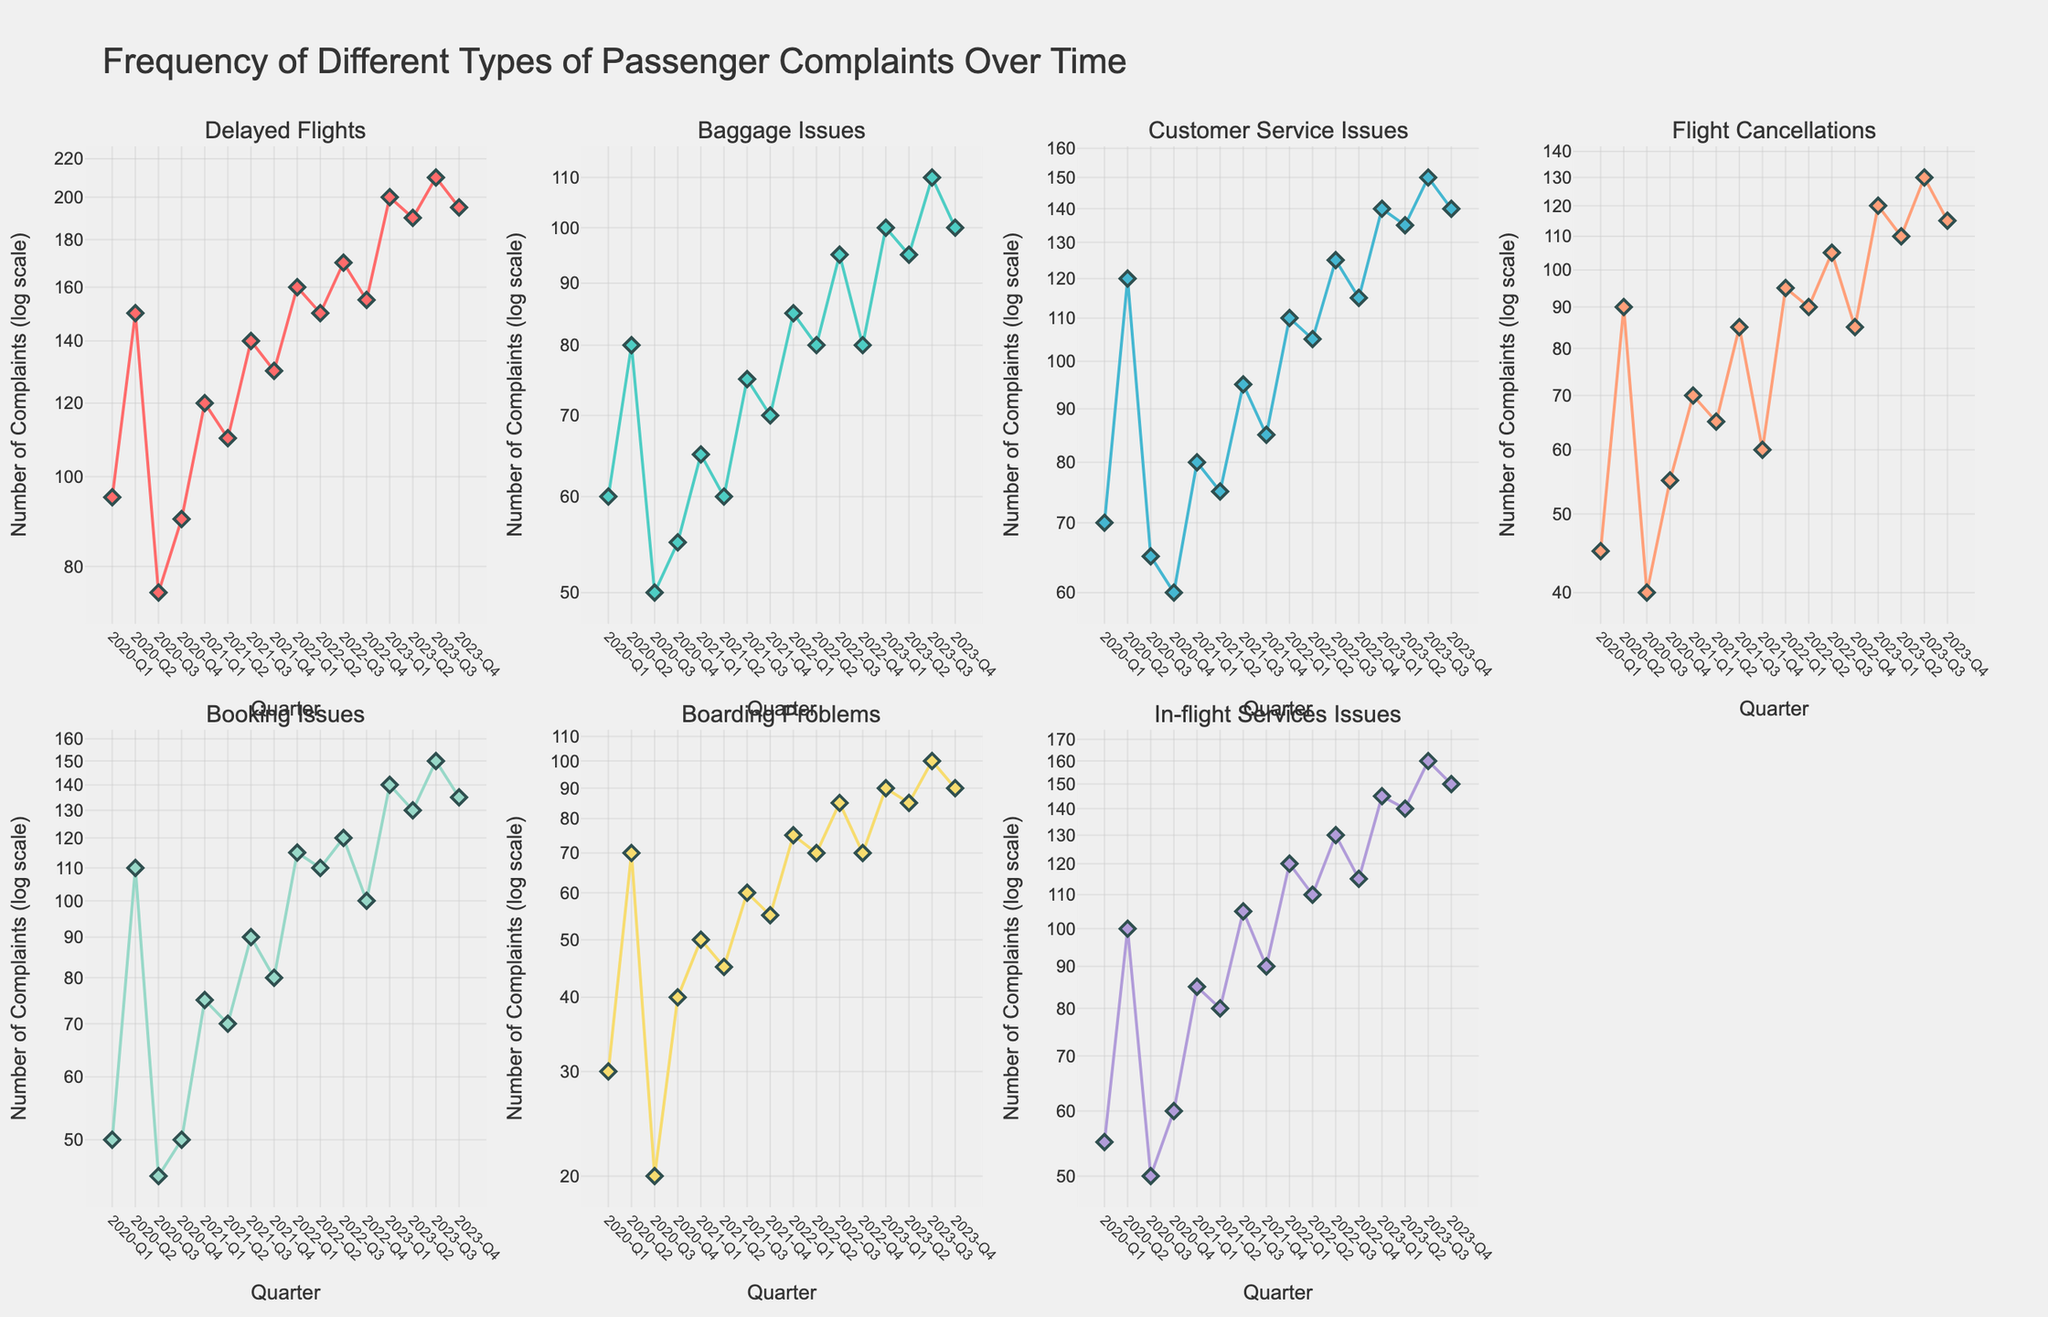What is the title of the figure? The title of the figure is positioned at the top of the plot area, indicating the main subject of the visualization.
Answer: Frequency of Different Types of Passenger Complaints Over Time How many types of passenger complaints are tracked in the figure? The figure contains individual subplots for each type of passenger complaint, which are indicated by the titles of each subplot.
Answer: Seven Which quarter exhibits the highest number of 'Customer Service Issues'? Close inspection of the subplot for 'Customer Service Issues' reveals that 2023-Q3 has the highest data point among all quarters.
Answer: 2023-Q3 By how much did the 'Delayed Flights' complaints increase from 2020-Q1 to 2023-Q2? Subtract the 'Delayed Flights' complaints value for 2020-Q1 from that of 2023-Q2 to find the difference: 190 (2023-Q2) - 95 (2020-Q1) = 95.
Answer: 95 Which type of complaint shows the most significant increase between 2022-Q3 and 2023-Q3? To determine this, subtract the values for each type of complaint in 2022-Q3 from those in 2023-Q3 and check which one has the highest difference. 'Booking Issues' show an increase from 120 to 150, i.e., a difference of 30, the highest among the complaints.
Answer: Booking Issues What is the general trend in the number of 'In-flight Services Issues' from 2020-Q1 to 2023-Q4? Examine the subplot for 'In-flight Services Issues' from start to end. The trend generally shows an increase in the number of complaints over time, especially visible with upward peaks in 2023.
Answer: Increasing Between which two quarters is the greatest decrease in 'Flight Cancellations' observed? Look for the largest drop between sequential data points in the 'Flight Cancellations' subplot. The greatest decrease is from 2023-Q3 (130) to 2023-Q4 (115).
Answer: 2023-Q3 to 2023-Q4 How do the 'Baggage Issues' in 2022-Q4 compare to those in 2020-Q4? Observing the values for these two quarters in the 'Baggage Issues' subplot, the values are 80 in 2022-Q4 and 55 in 2020-Q4. 2022-Q4 has a higher count.
Answer: Higher in 2022-Q4 Which subplots use a log scale for the y-axis? Since all subplots are stated to use a log scale for the y-axis, this applies to all individual plots for each type of complaint.
Answer: All subplots 